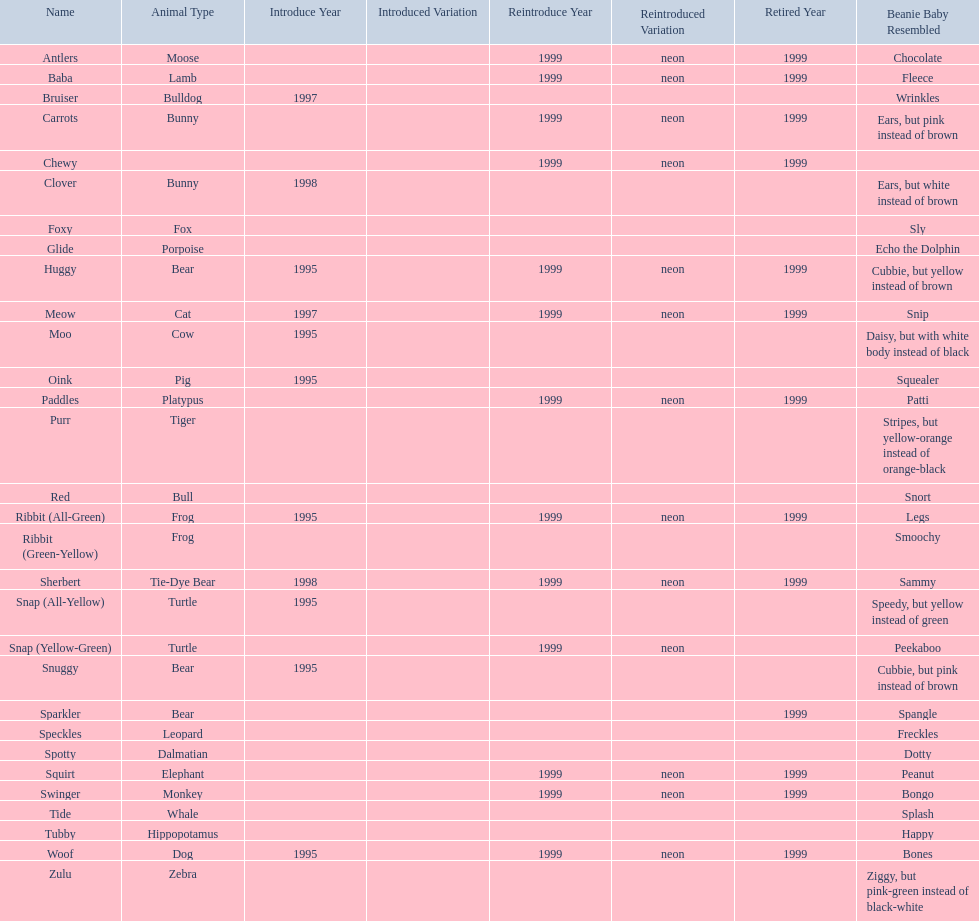Which of the listed pillow pals lack information in at least 3 categories? Chewy, Foxy, Glide, Purr, Red, Ribbit (Green-Yellow), Speckles, Spotty, Tide, Tubby, Zulu. Of those, which one lacks information in the animal type category? Chewy. 